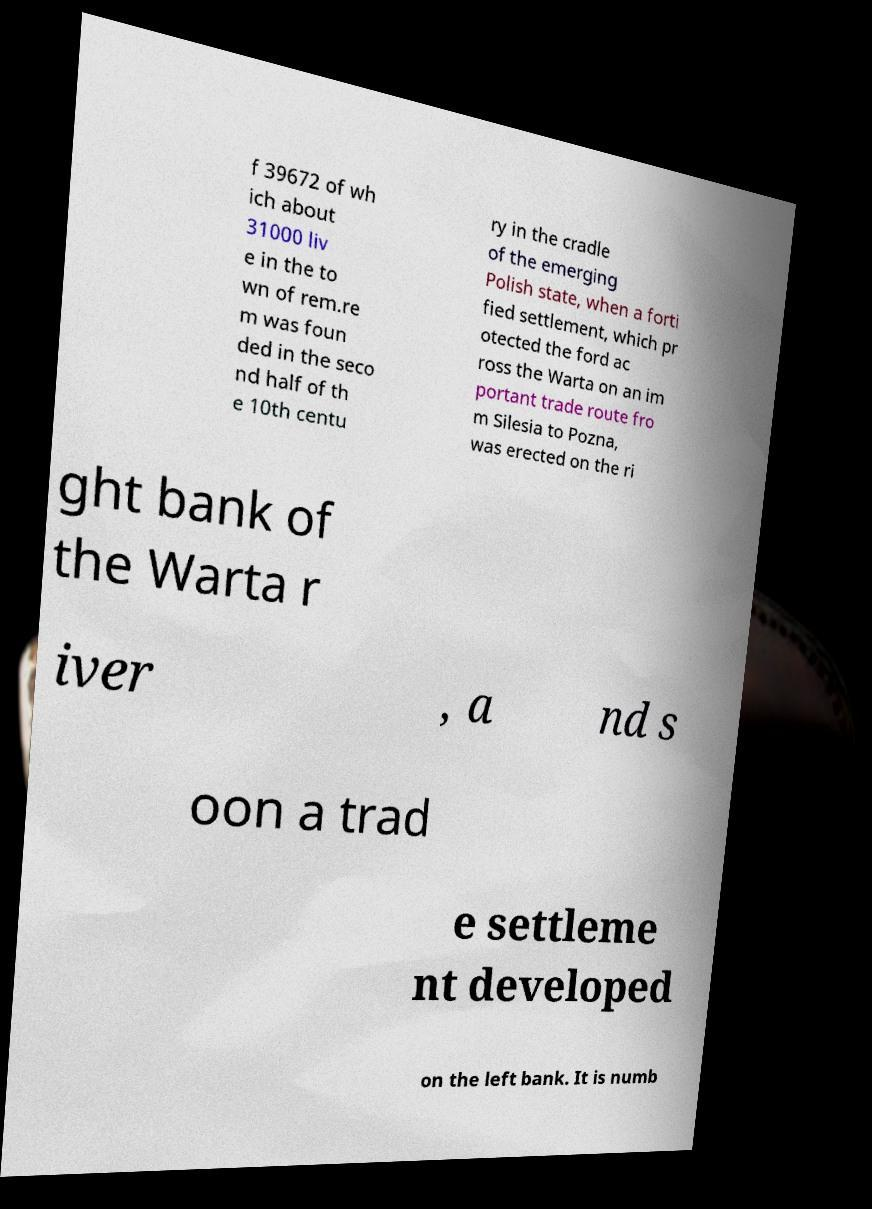There's text embedded in this image that I need extracted. Can you transcribe it verbatim? f 39672 of wh ich about 31000 liv e in the to wn of rem.re m was foun ded in the seco nd half of th e 10th centu ry in the cradle of the emerging Polish state, when a forti fied settlement, which pr otected the ford ac ross the Warta on an im portant trade route fro m Silesia to Pozna, was erected on the ri ght bank of the Warta r iver , a nd s oon a trad e settleme nt developed on the left bank. It is numb 